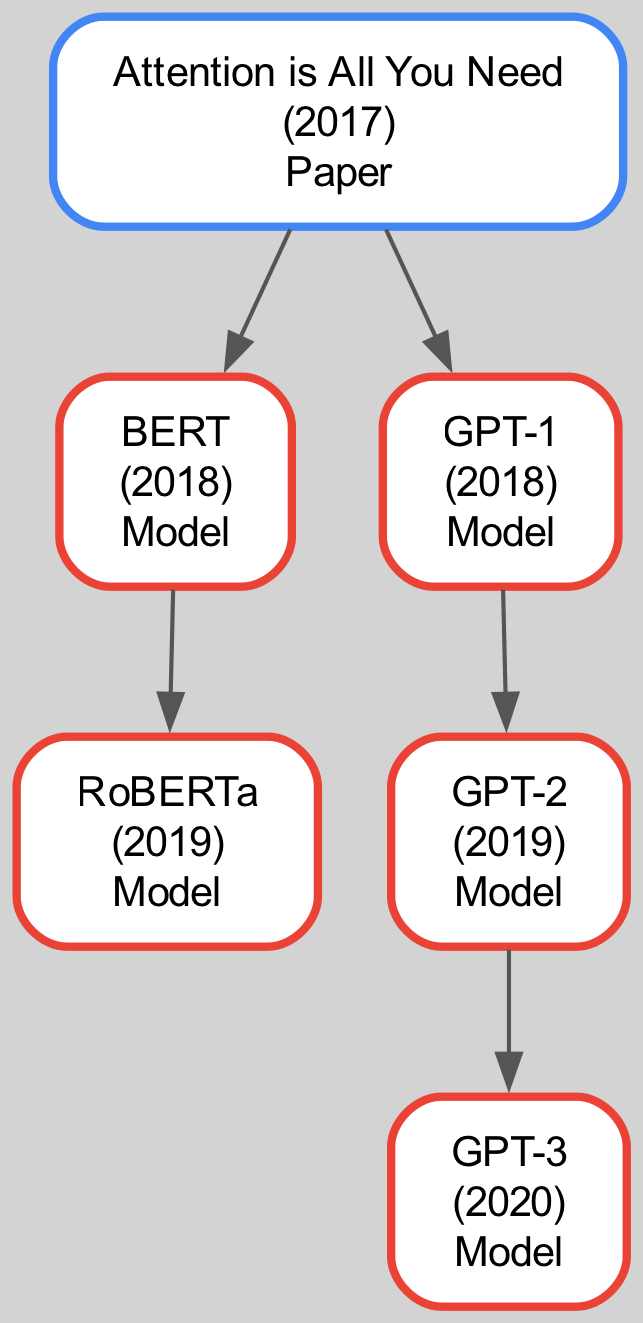What is the title of the foundational paper for transformer models? The family tree starts with the paper "Attention is All You Need," which is indicated as the root node in the diagram.
Answer: Attention is All You Need In what year was BERT introduced? The diagram shows that BERT is a descendant of the "Attention is All You Need" paper, and it has a publication date listed as 2018.
Answer: 2018 Who are the contributors of GPT-2? The diagram reveals that GPT-2 is a descendant of GPT-1, and lists the contributors to GPT-2 as Alec Radford, Jeffrey Wu, Rewon Child, David Luan, Dario Amodei, and Ilya Sutskever next to its node.
Answer: Alec Radford, Jeffrey Wu, Rewon Child, David Luan, Dario Amodei, Ilya Sutskever How many descendants does the paper "Attention is All You Need" have? By observing the diagram, "Attention is All You Need" has two direct descendants: BERT and GPT-1. Thus, it has a total of 2 descendants.
Answer: 2 Which model is a direct descendant of BERT? The family tree indicates that RoBERTa is the only direct descendant of BERT, as shown in the descendants list of the BERT node.
Answer: RoBERTa Which model comes after GPT-1 chronologically? In the diagram, GPT-1 is followed by GPT-2 as indicated by its placement directly beneath GPT-1, showing the chronological development.
Answer: GPT-2 What is the relationship between GPT-2 and GPT-3? The diagram illustrates that GPT-3 is a descendant of GPT-2, meaning that GPT-2 directly contributes to the development of GPT-3.
Answer: GPT-3 is a descendant of GPT-2 Who are the contributors to the foundational paper on transformers? The diagram lists the contributors to "Attention is All You Need" as Ashish Vaswani, Noam Shazeer, Niki Parmar, Jakob Uszkoreit, Llion Jones, Aidan N. Gomez, Lukasz Kaiser, and Illia Polosukhin.
Answer: Ashish Vaswani, Noam Shazeer, Niki Parmar, Jakob Uszkoreit, Llion Jones, Aidan N. Gomez, Lukasz Kaiser, Illia Polosukhin What is the order of models starting from BERT? The family tree shows that starting from BERT, the order of models is BERT followed by RoBERTa, indicating RoBERTa is a development based on BERT.
Answer: BERT, RoBERTa 